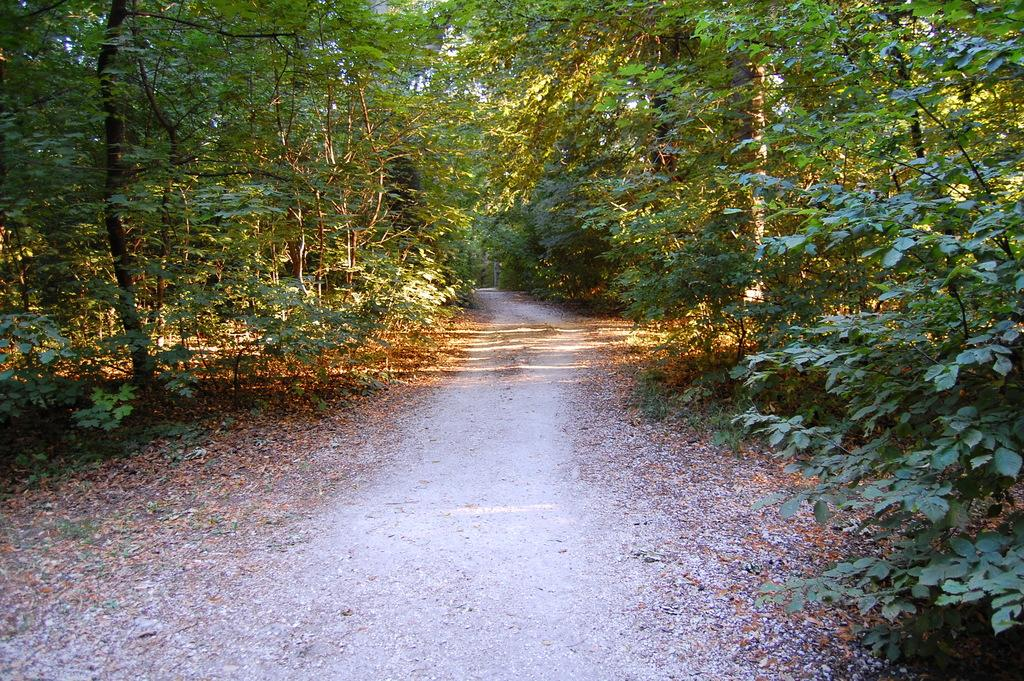What is located in the center of the image? There is a way in the center of the image. What type of vegetation can be seen on the right side of the image? There are trees on the right side of the image. What type of vegetation can be seen on the left side of the image? There are trees on the left side of the image. What type of cake can be seen on the left side of the image? There is no cake present in the image; it features a way and trees on both sides. 